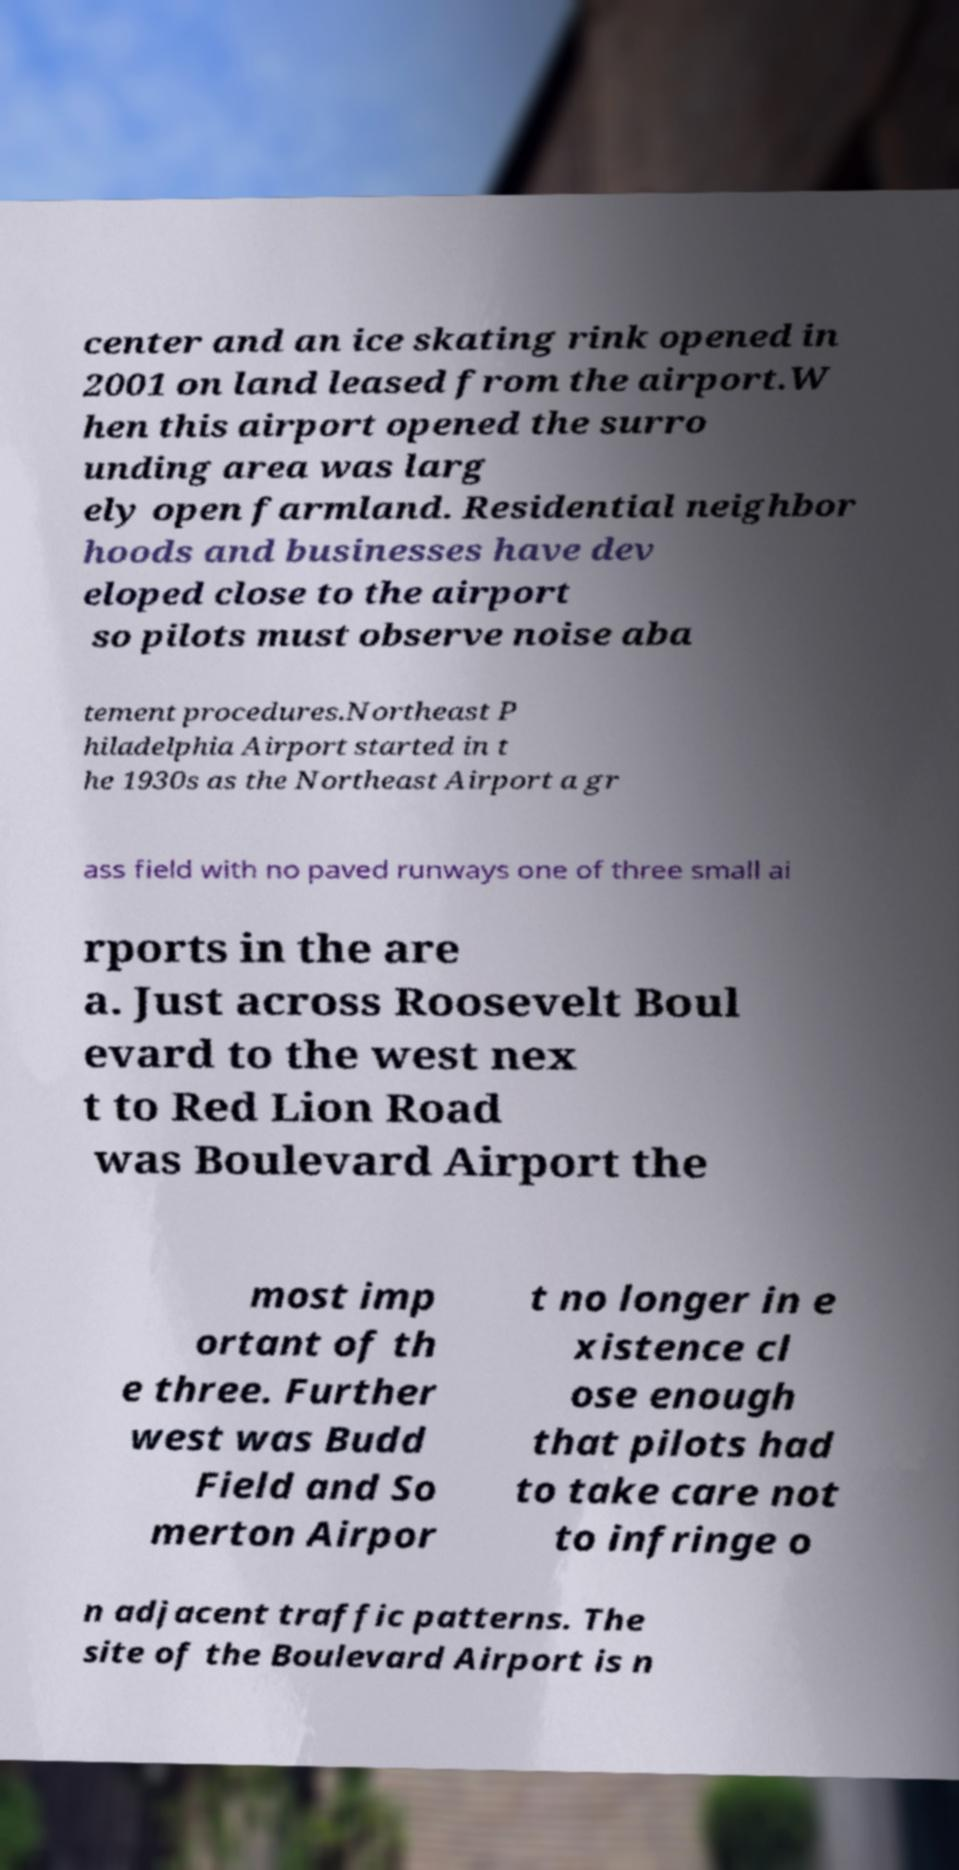Please identify and transcribe the text found in this image. center and an ice skating rink opened in 2001 on land leased from the airport.W hen this airport opened the surro unding area was larg ely open farmland. Residential neighbor hoods and businesses have dev eloped close to the airport so pilots must observe noise aba tement procedures.Northeast P hiladelphia Airport started in t he 1930s as the Northeast Airport a gr ass field with no paved runways one of three small ai rports in the are a. Just across Roosevelt Boul evard to the west nex t to Red Lion Road was Boulevard Airport the most imp ortant of th e three. Further west was Budd Field and So merton Airpor t no longer in e xistence cl ose enough that pilots had to take care not to infringe o n adjacent traffic patterns. The site of the Boulevard Airport is n 